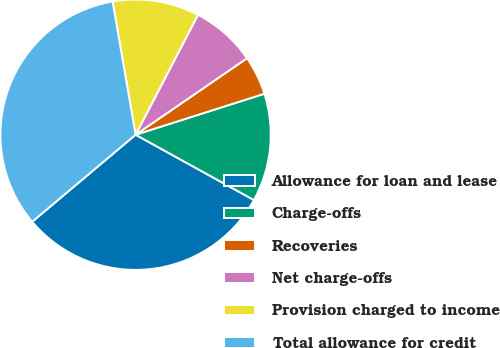Convert chart. <chart><loc_0><loc_0><loc_500><loc_500><pie_chart><fcel>Allowance for loan and lease<fcel>Charge-offs<fcel>Recoveries<fcel>Net charge-offs<fcel>Provision charged to income<fcel>Total allowance for credit<nl><fcel>30.84%<fcel>12.93%<fcel>4.67%<fcel>7.79%<fcel>10.36%<fcel>33.41%<nl></chart> 